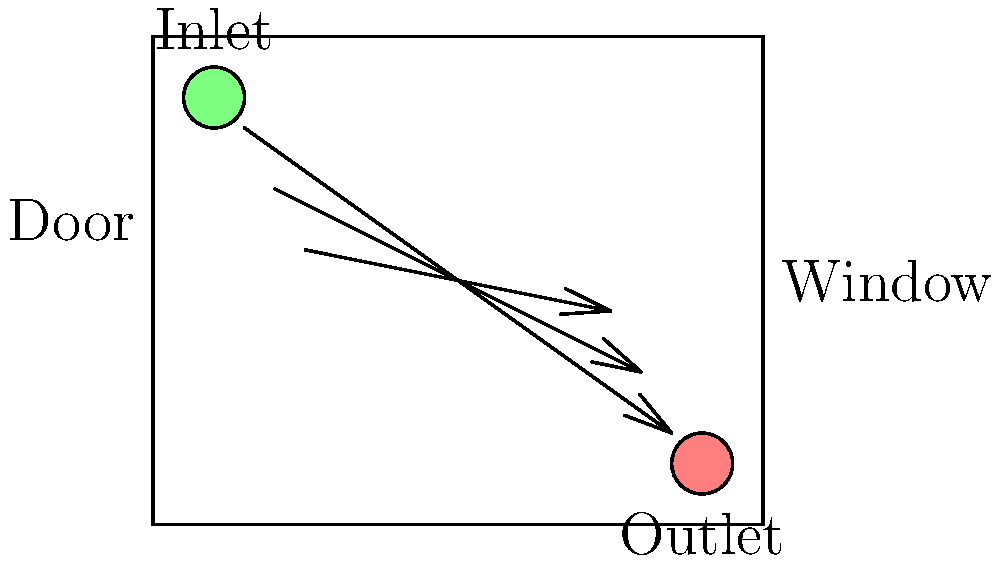In the salon room layout shown, which airflow pattern is most effective for proper ventilation and why? To determine the most effective airflow pattern for proper ventilation in a salon room, we need to consider several factors:

1. Fresh air intake: The ventilation inlet (green circle) is located near the ceiling on the left side of the room.

2. Air exhaust: The ventilation outlet (red circle) is positioned near the floor on the right side of the room.

3. Airflow direction: The arrows indicate that air moves diagonally from the upper left to the lower right of the room.

4. Room layout: The door is on the left side, and the window is on the right side of the room.

The most effective airflow pattern for proper ventilation is the one shown in the diagram because:

a) It follows the principle of displacement ventilation, where fresh air enters from a high point and exits from a low point.

b) This pattern creates a natural flow that helps remove contaminants and odors from the breathing zone.

c) The diagonal flow ensures that air reaches all corners of the room, preventing stagnant areas.

d) The inlet and outlet positions take advantage of the fact that warm air rises and cool air sinks, enhancing air circulation.

e) The airflow pattern moves from the door side to the window side, which can help in creating a slight negative pressure in the room, preventing odors from escaping into other areas of the salon.

This setup is particularly beneficial for a wellness practitioner offering services like massage or acupuncture, as it helps maintain a fresh and clean environment for clients.
Answer: Diagonal flow from upper left to lower right 